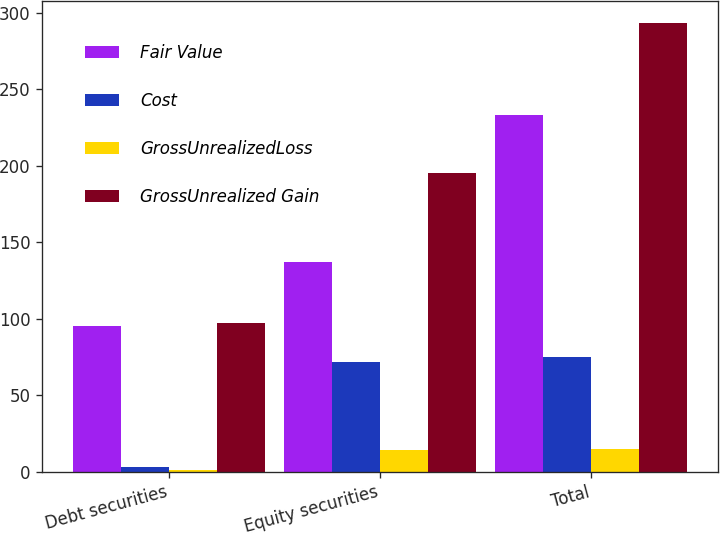<chart> <loc_0><loc_0><loc_500><loc_500><stacked_bar_chart><ecel><fcel>Debt securities<fcel>Equity securities<fcel>Total<nl><fcel>Fair Value<fcel>95<fcel>137<fcel>233<nl><fcel>Cost<fcel>3<fcel>72<fcel>75<nl><fcel>GrossUnrealizedLoss<fcel>1<fcel>14<fcel>15<nl><fcel>GrossUnrealized Gain<fcel>97<fcel>195<fcel>293<nl></chart> 